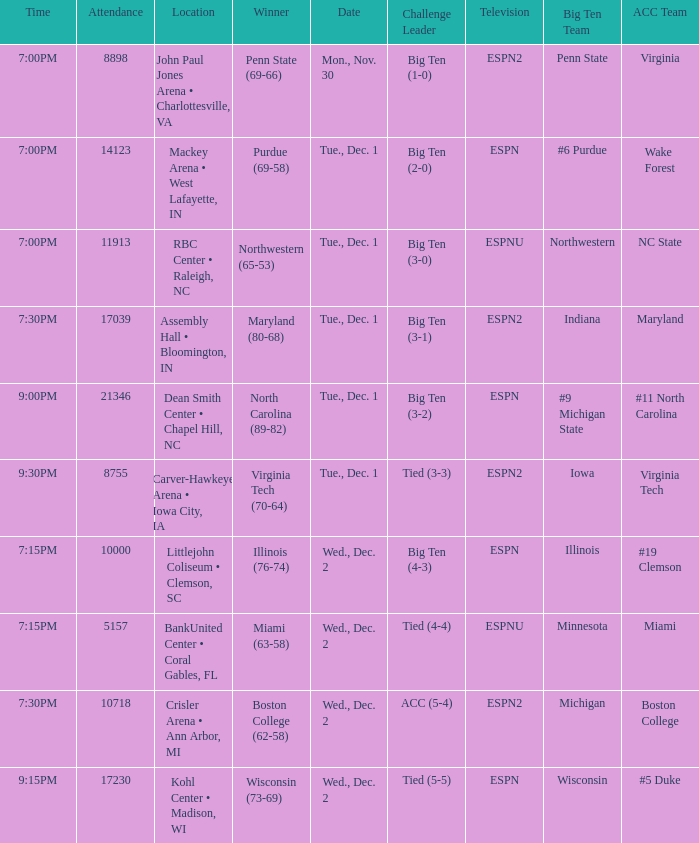Name the location for illinois Littlejohn Coliseum • Clemson, SC. 